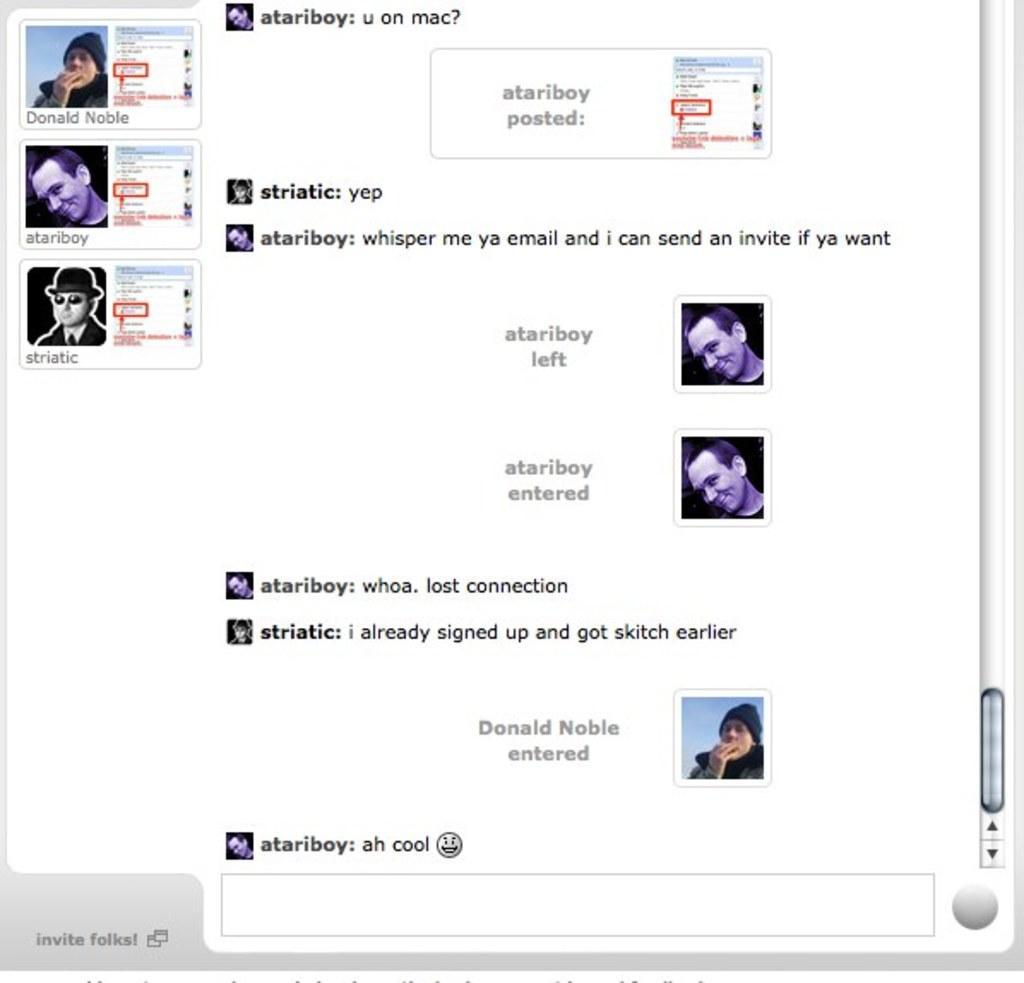Can you describe this image briefly? In this image there is text, there are persons, there is a scroll bar towards the right of the image, there is a text towards the bottom of the image, the background of the image is white in color. 